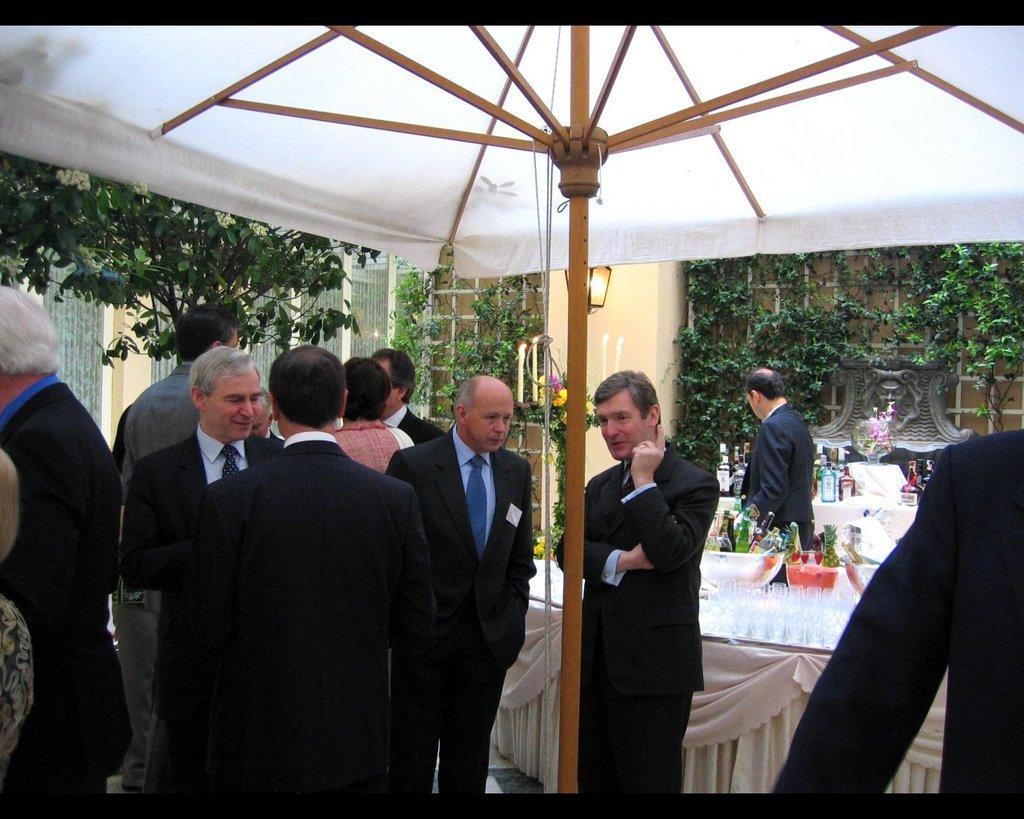Can you describe this image briefly? In this image there are a few tables arranger with some glasses, drinks, flower pots and other objects placed on it, there is a canopy, beneath the canopy there are a few people standing with a smile on their face. In the background there are trees, plants and a lamp is hanging on the wall. 